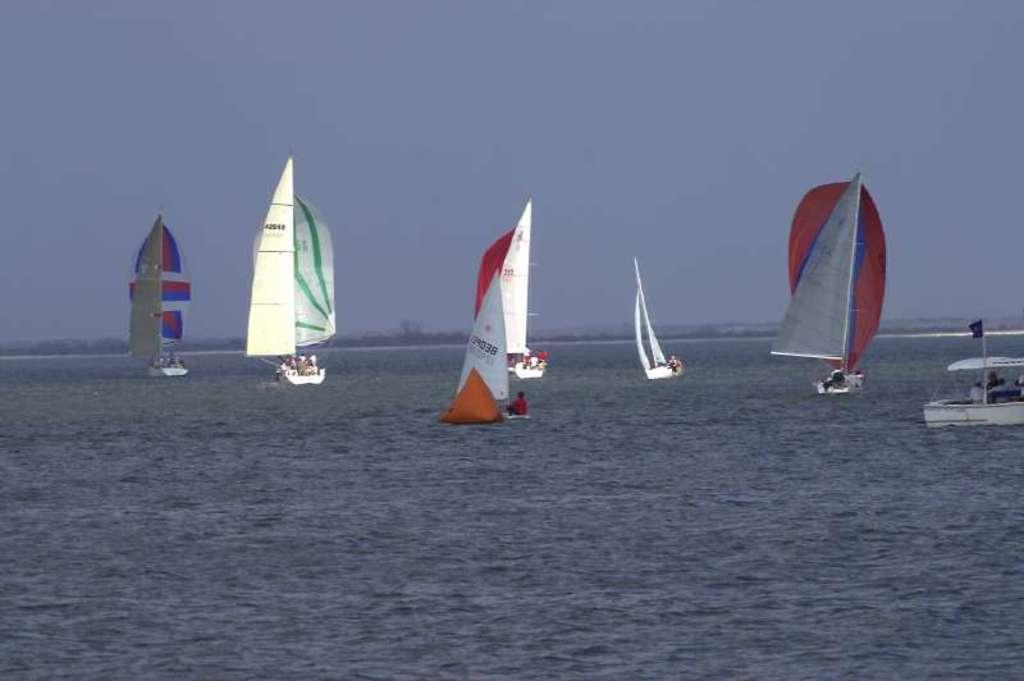Please provide a concise description of this image. In this image in the front there is water. In the background there are boats sailing on the water and there are persons inside the boats and the sky is cloudy. 